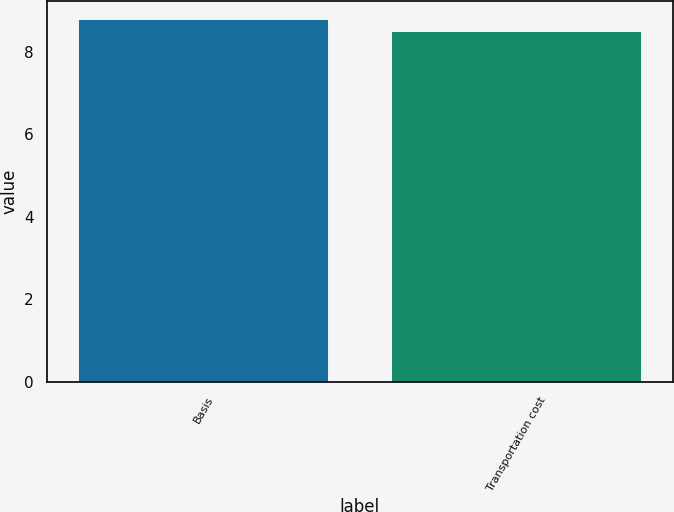Convert chart. <chart><loc_0><loc_0><loc_500><loc_500><bar_chart><fcel>Basis<fcel>Transportation cost<nl><fcel>8.8<fcel>8.5<nl></chart> 